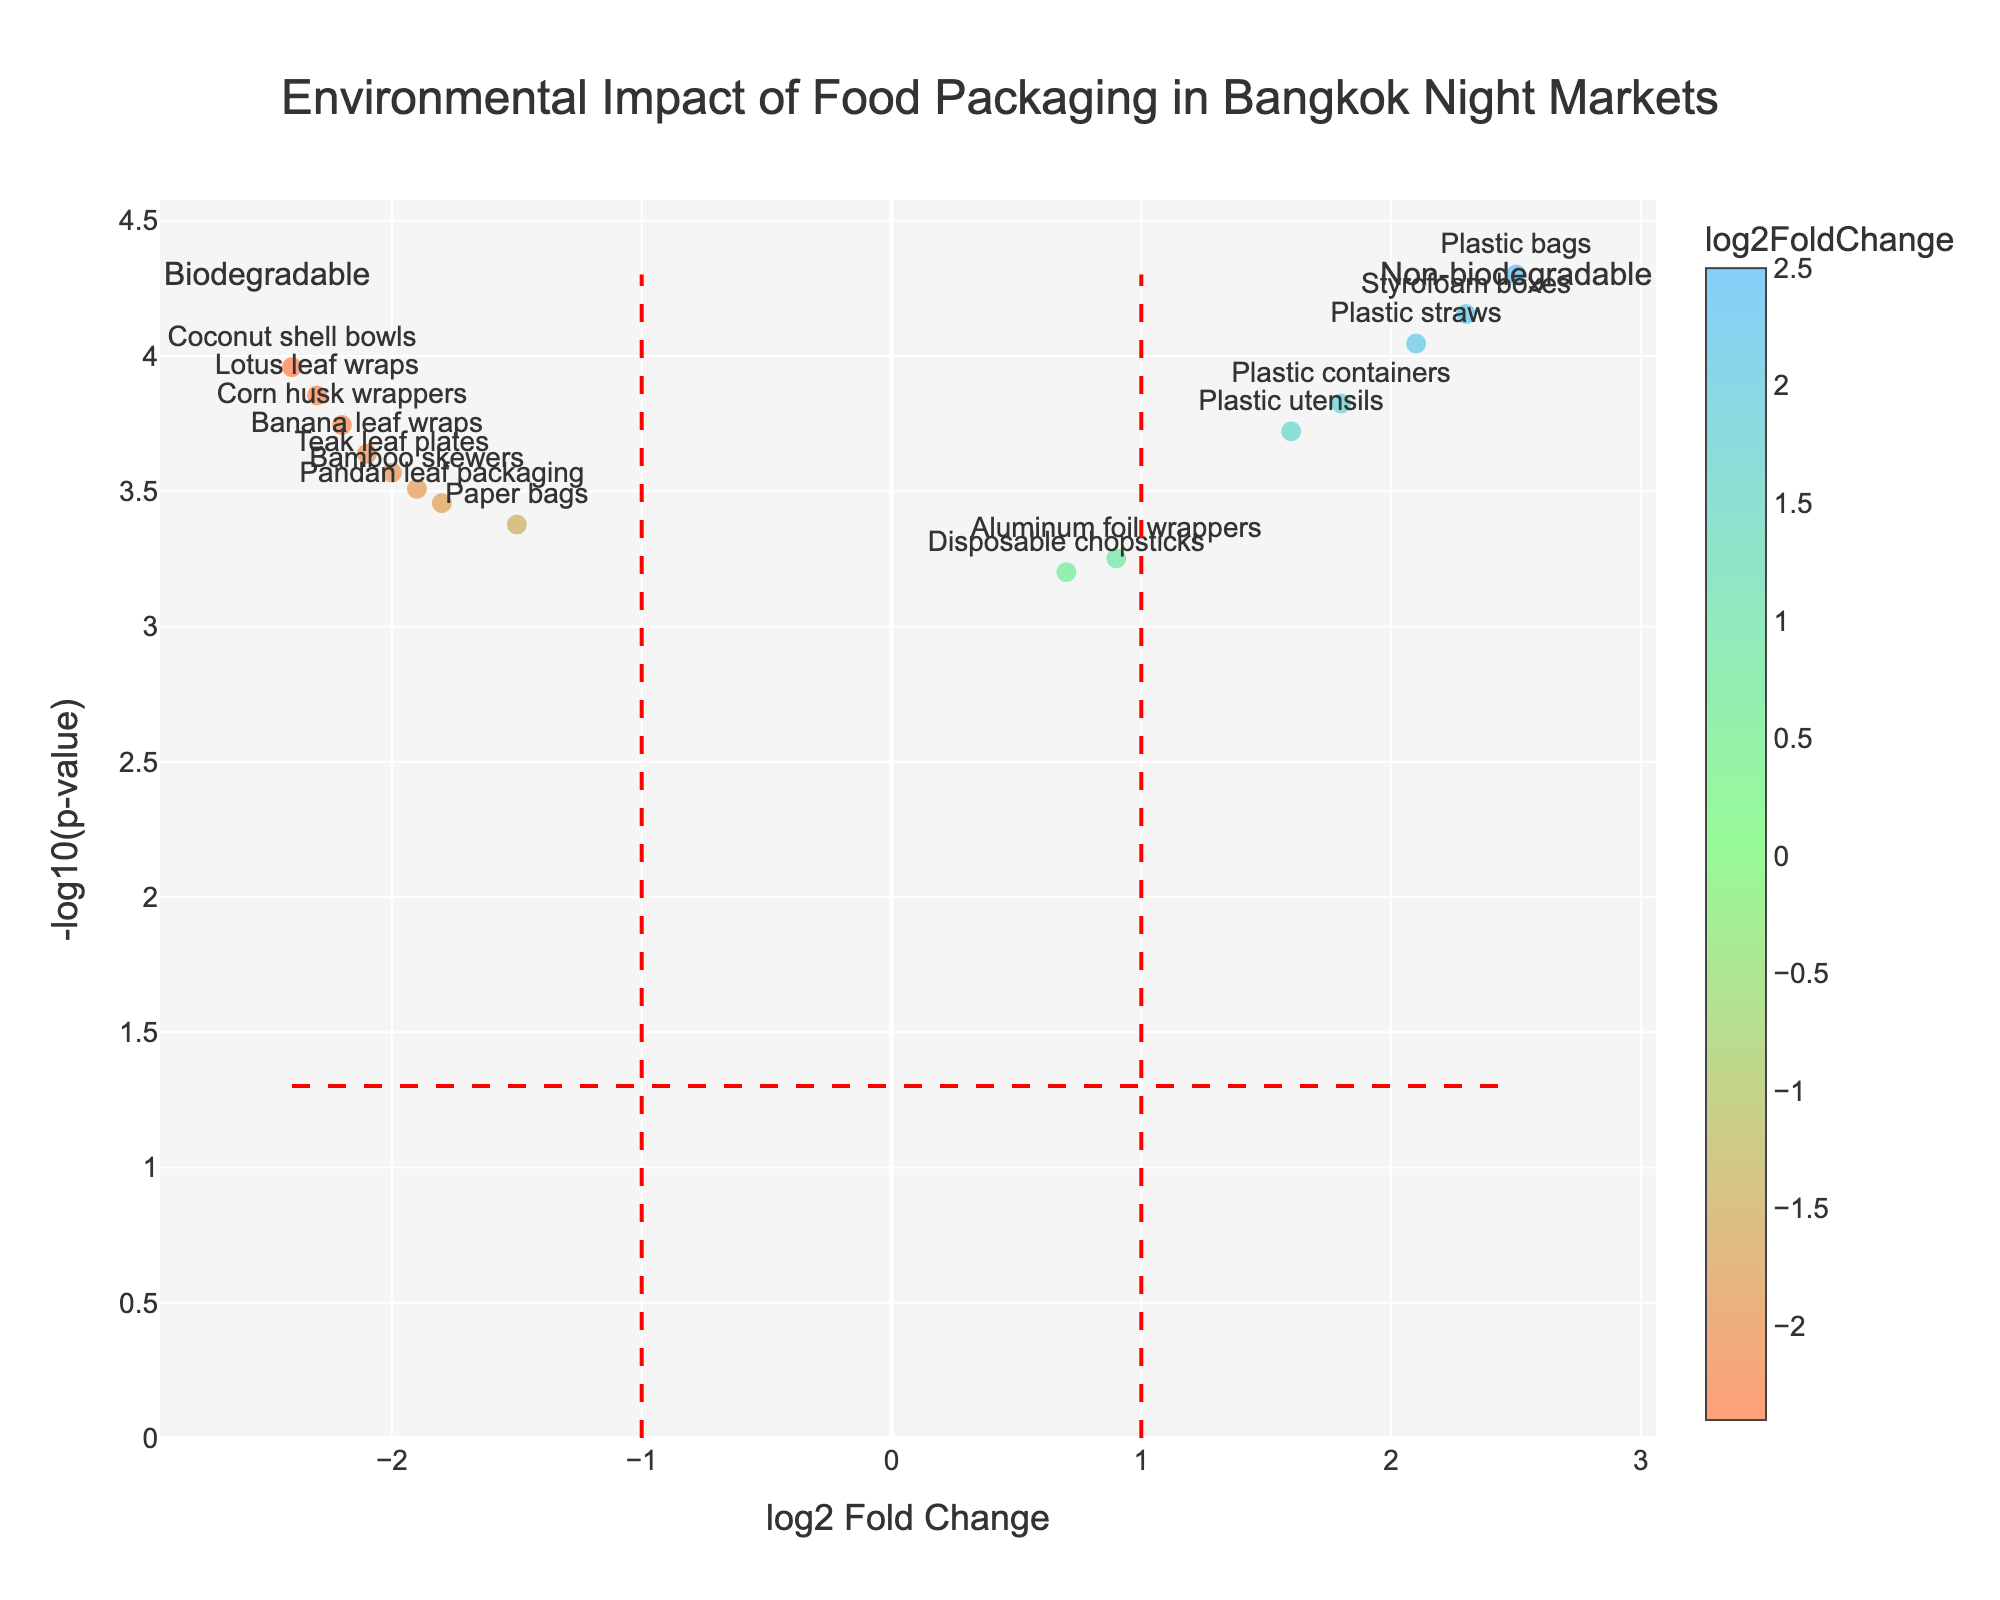What is the title of the plot? The title is usually displayed at the top of the plot. Here it reads: "Environmental Impact of Food Packaging in Bangkok Night Markets".
Answer: Environmental Impact of Food Packaging in Bangkok Night Markets How many data points are plotted on the graph? You can count the number of points visible on the plot to determine this. Each point represents an item.
Answer: 15 Which item has the highest negative log2FoldChange? Look for the point with the lowest value on the x-axis (log2FoldChange) and check its label.
Answer: Coconut shell bowls What is the p-value for Plastic containers? Use the hover text to find the p-value for this specific item labeled on the plot.
Answer: 0.00015 Compare the environmental impact on plastic bags and banana leaf wraps. Which has a higher log2FoldChange? Check the x-axis values for both data points. The one with a higher x-axis value has a higher log2FoldChange.
Answer: Plastic bags Can you identify any biodegradable packaging with significant negative environmental impact? Biodegradable packaging materials will have negative log2FoldChange values. Check the y-axis (-log10(p-value)) to ensure significance. Coconut shell bowls, Corn husk wrappers, etc.
Answer: Yes, Coconut shell bowls What's the criteria for marking data points as significant on the plot? The dashed horizontal red line represents the significance threshold based on p-value, typically at -log10(0.05). Points above this line are significant.
Answer: Above -log10(0.05) How do the environmental impacts of Teak leaf plates and aluminum foil wrappers compare? Compare their log2FoldChange and -log10(p-value) to understand their relative impacts. Teak leaf plates have a more negative log2FoldChange, indicating a lower impact.
Answer: Teak leaf plates have a lower impact Which items are considered non-biodegradable with a positive log2FoldChange? Look for data points on the positive side of the x-axis with significant p-values. Labels such as Plastic containers and Plastic bags will be there.
Answer: Plastic containers, Plastic bags, etc Is there any item with a fold change exactly at zero? Check the plot for any data point that aligns exactly on the y-axis (log2 Fold Change = 0).
Answer: No 